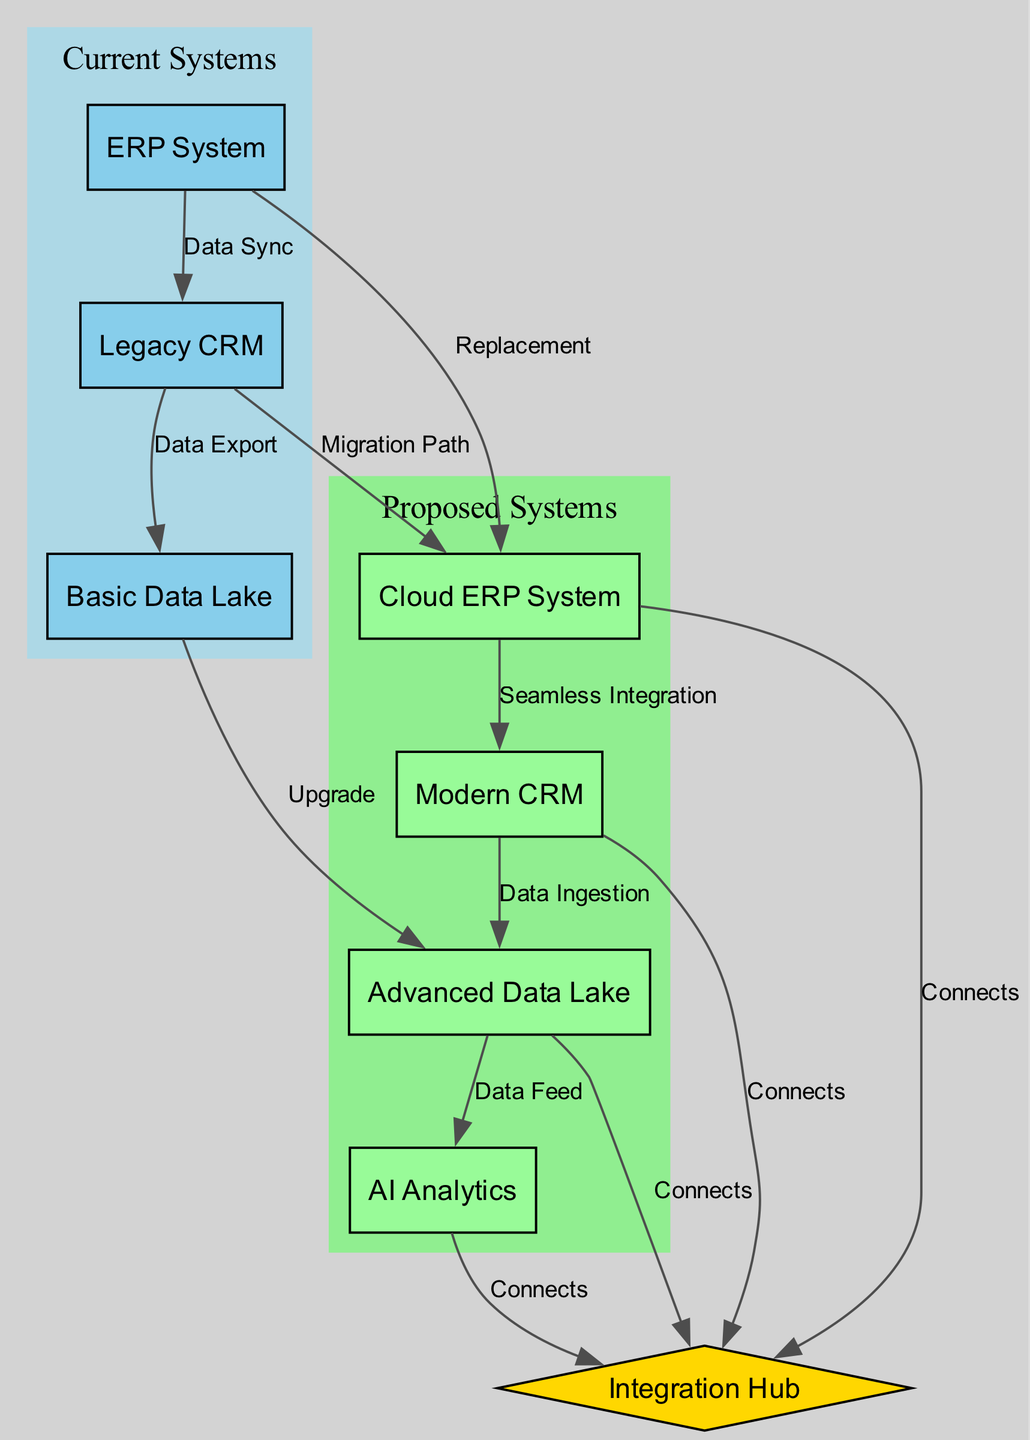What is the total number of systems in the current systems category? In the diagram, the current systems category includes three systems: ERP System, Legacy CRM, and Basic Data Lake. Therefore, the total count is simply the number of these systems.
Answer: 3 Which system in the proposed category has a connection labeled "Data Feed"? The connection labeled "Data Feed" is directly from the Advanced Data Lake to the AI Analytics system. Therefore, the system from which this connection originates is Advanced Data Lake.
Answer: Advanced Data Lake How many edges connect to the Integration Hub? The Integration Hub has connections from four systems: Cloud ERP System, Modern CRM, Advanced Data Lake, and AI Analytics. By counting these edges in the diagram, we find there are a total of four connections leading to the Integration Hub.
Answer: 4 What does the edge from the Legacy CRM to the Cloud ERP System represent? The edge between Legacy CRM and Cloud ERP System is labeled "Migration Path," indicating a relocation or transition process from the older system to the new system. Thus, this edge signifies the planned changeover between these systems.
Answer: Migration Path Which system provides the data ingestion functionality in the proposed systems? The Modern CRM system is connected to the Advanced Data Lake via an edge labeled "Data Ingestion." This indicates that Modern CRM is responsible for data ingestion activity within the proposed technology stack.
Answer: Modern CRM What kind of connection exists between the Basic Data Lake and Advanced Data Lake? The edge labeled "Upgrade" indicates that Basic Data Lake supports a transition to the Advanced Data Lake, thus identifying the nature of this connection as an upgrade process.
Answer: Upgrade How many systems in the proposed category are integrated with the Integration Hub? The proposed category has three systems: Cloud ERP System, Modern CRM, and Advanced Data Lake, which all connect to the Integration Hub, making a total of three systems integrated with it.
Answer: 3 What is the purpose of the edge labeled "Seamless Integration"? This edge signifies that there is a cohesive collaboration between the Cloud ERP System and Modern CRM. It implies that these two systems are designed to work together without disruptions.
Answer: Seamless Integration 